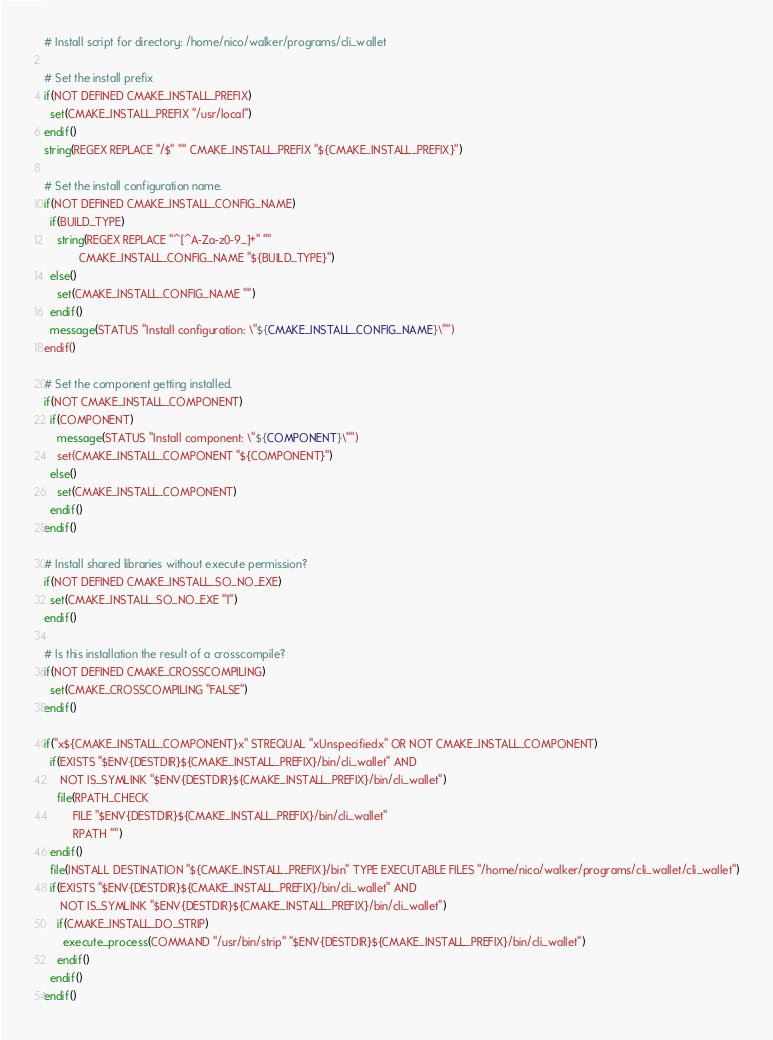<code> <loc_0><loc_0><loc_500><loc_500><_CMake_># Install script for directory: /home/nico/walker/programs/cli_wallet

# Set the install prefix
if(NOT DEFINED CMAKE_INSTALL_PREFIX)
  set(CMAKE_INSTALL_PREFIX "/usr/local")
endif()
string(REGEX REPLACE "/$" "" CMAKE_INSTALL_PREFIX "${CMAKE_INSTALL_PREFIX}")

# Set the install configuration name.
if(NOT DEFINED CMAKE_INSTALL_CONFIG_NAME)
  if(BUILD_TYPE)
    string(REGEX REPLACE "^[^A-Za-z0-9_]+" ""
           CMAKE_INSTALL_CONFIG_NAME "${BUILD_TYPE}")
  else()
    set(CMAKE_INSTALL_CONFIG_NAME "")
  endif()
  message(STATUS "Install configuration: \"${CMAKE_INSTALL_CONFIG_NAME}\"")
endif()

# Set the component getting installed.
if(NOT CMAKE_INSTALL_COMPONENT)
  if(COMPONENT)
    message(STATUS "Install component: \"${COMPONENT}\"")
    set(CMAKE_INSTALL_COMPONENT "${COMPONENT}")
  else()
    set(CMAKE_INSTALL_COMPONENT)
  endif()
endif()

# Install shared libraries without execute permission?
if(NOT DEFINED CMAKE_INSTALL_SO_NO_EXE)
  set(CMAKE_INSTALL_SO_NO_EXE "1")
endif()

# Is this installation the result of a crosscompile?
if(NOT DEFINED CMAKE_CROSSCOMPILING)
  set(CMAKE_CROSSCOMPILING "FALSE")
endif()

if("x${CMAKE_INSTALL_COMPONENT}x" STREQUAL "xUnspecifiedx" OR NOT CMAKE_INSTALL_COMPONENT)
  if(EXISTS "$ENV{DESTDIR}${CMAKE_INSTALL_PREFIX}/bin/cli_wallet" AND
     NOT IS_SYMLINK "$ENV{DESTDIR}${CMAKE_INSTALL_PREFIX}/bin/cli_wallet")
    file(RPATH_CHECK
         FILE "$ENV{DESTDIR}${CMAKE_INSTALL_PREFIX}/bin/cli_wallet"
         RPATH "")
  endif()
  file(INSTALL DESTINATION "${CMAKE_INSTALL_PREFIX}/bin" TYPE EXECUTABLE FILES "/home/nico/walker/programs/cli_wallet/cli_wallet")
  if(EXISTS "$ENV{DESTDIR}${CMAKE_INSTALL_PREFIX}/bin/cli_wallet" AND
     NOT IS_SYMLINK "$ENV{DESTDIR}${CMAKE_INSTALL_PREFIX}/bin/cli_wallet")
    if(CMAKE_INSTALL_DO_STRIP)
      execute_process(COMMAND "/usr/bin/strip" "$ENV{DESTDIR}${CMAKE_INSTALL_PREFIX}/bin/cli_wallet")
    endif()
  endif()
endif()

</code> 